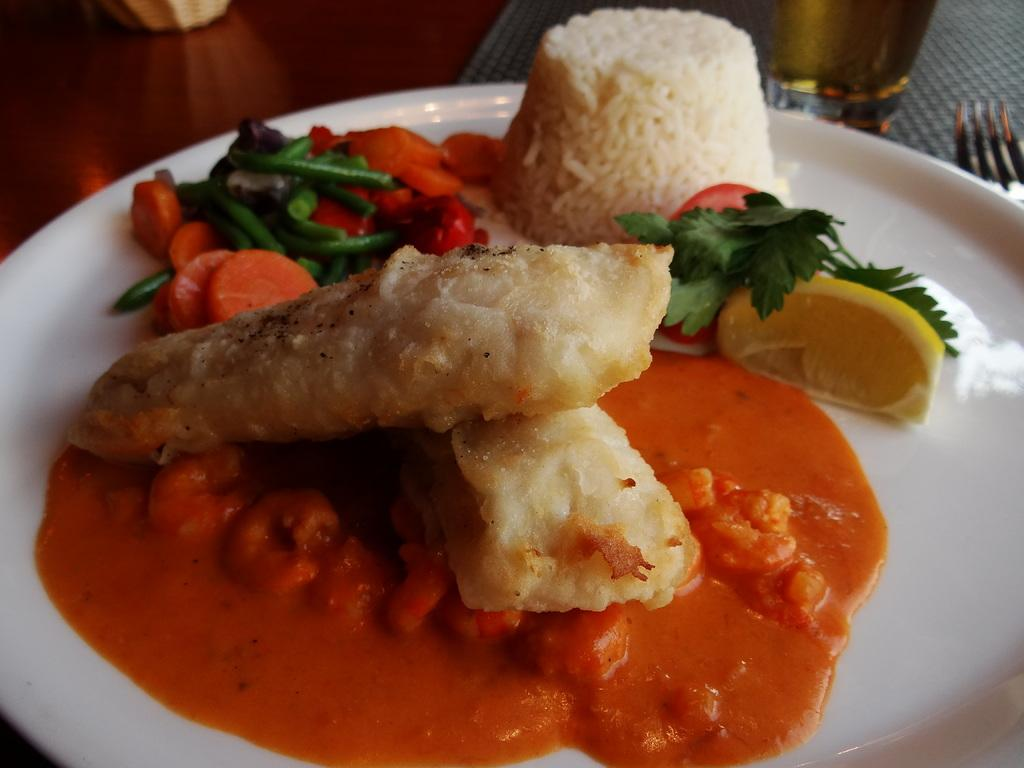What type of furniture is present in the image? There is a table in the image. What is placed on the table? There is a white color plate on the table. What utensil can be seen on the table? There is a fork on the table. What is on the plate? There is a dish on the plate. How many seats are available at the table in the image? The image does not show any seats or chairs, so it is not possible to determine the number of available seats. 